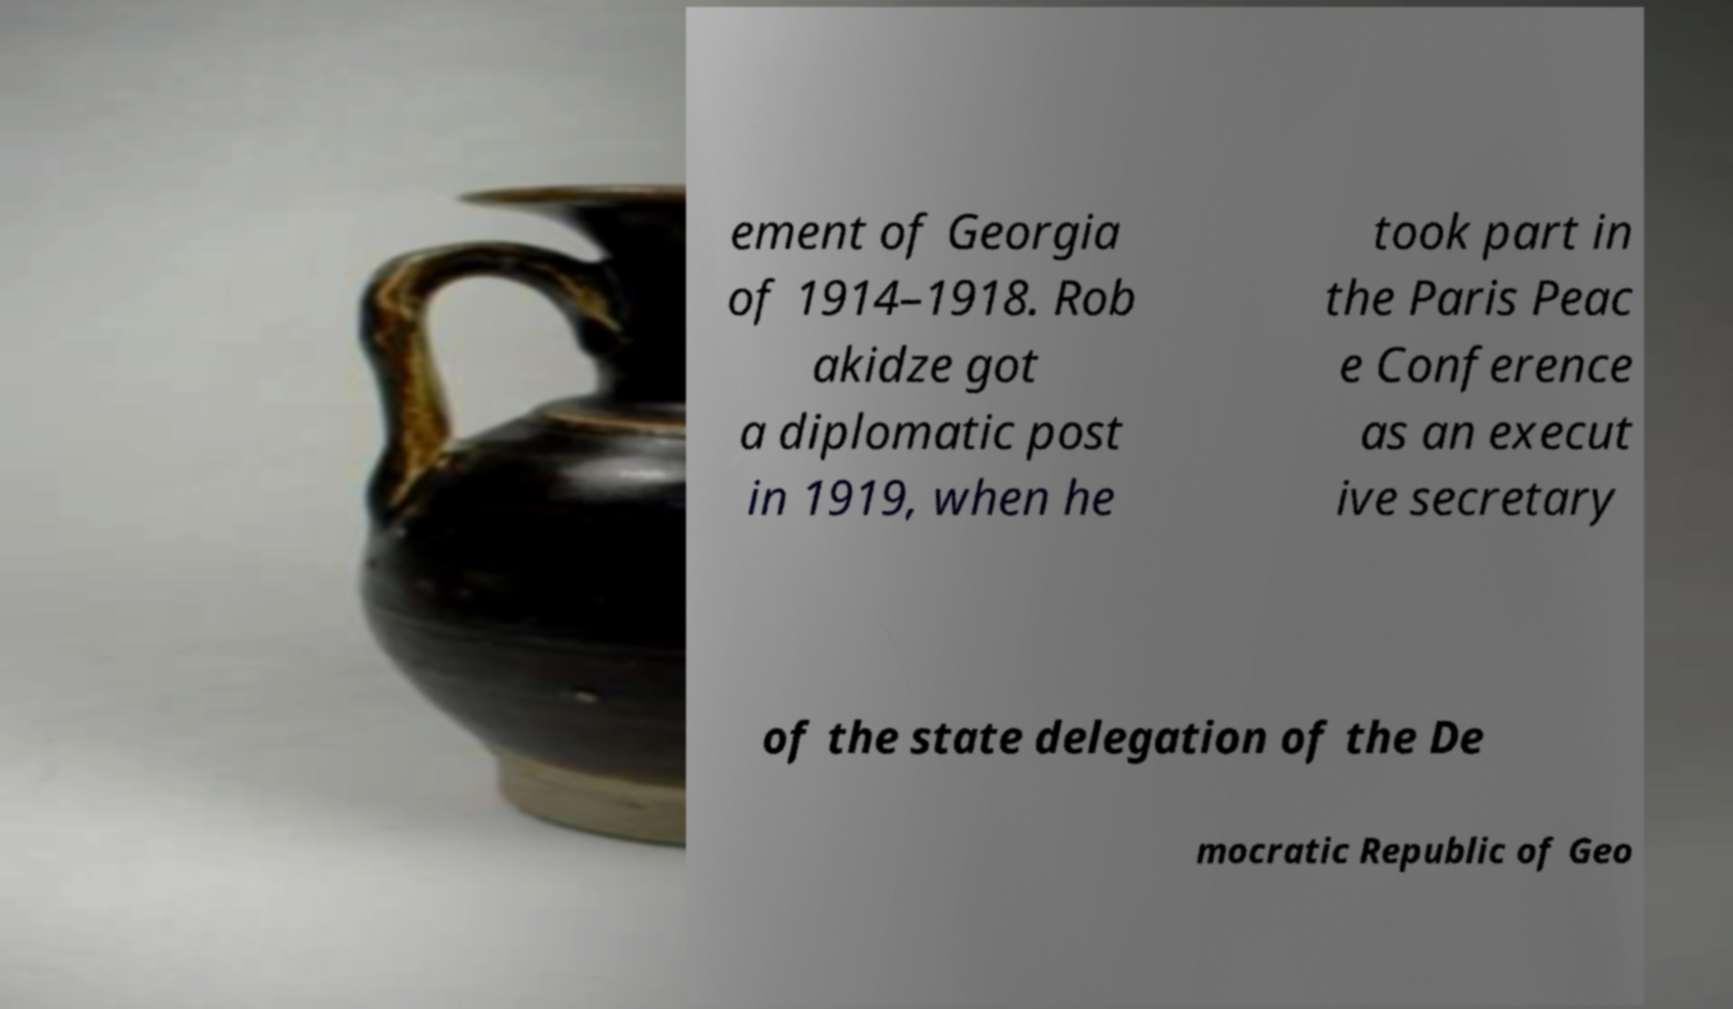Please identify and transcribe the text found in this image. ement of Georgia of 1914–1918. Rob akidze got a diplomatic post in 1919, when he took part in the Paris Peac e Conference as an execut ive secretary of the state delegation of the De mocratic Republic of Geo 